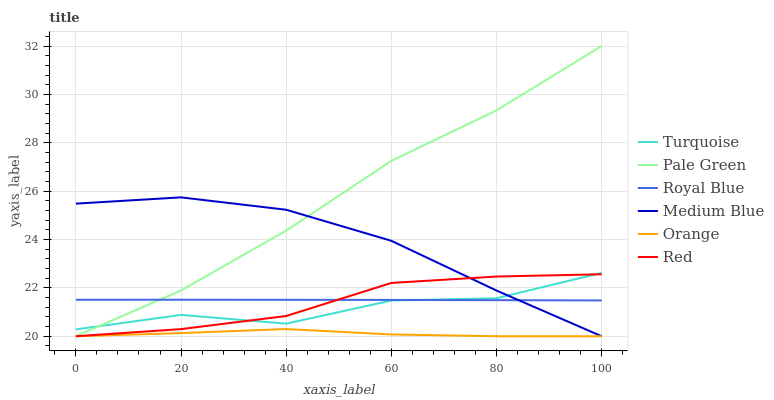Does Orange have the minimum area under the curve?
Answer yes or no. Yes. Does Pale Green have the maximum area under the curve?
Answer yes or no. Yes. Does Medium Blue have the minimum area under the curve?
Answer yes or no. No. Does Medium Blue have the maximum area under the curve?
Answer yes or no. No. Is Royal Blue the smoothest?
Answer yes or no. Yes. Is Turquoise the roughest?
Answer yes or no. Yes. Is Medium Blue the smoothest?
Answer yes or no. No. Is Medium Blue the roughest?
Answer yes or no. No. Does Royal Blue have the lowest value?
Answer yes or no. No. Does Medium Blue have the highest value?
Answer yes or no. No. Is Orange less than Royal Blue?
Answer yes or no. Yes. Is Turquoise greater than Orange?
Answer yes or no. Yes. Does Orange intersect Royal Blue?
Answer yes or no. No. 